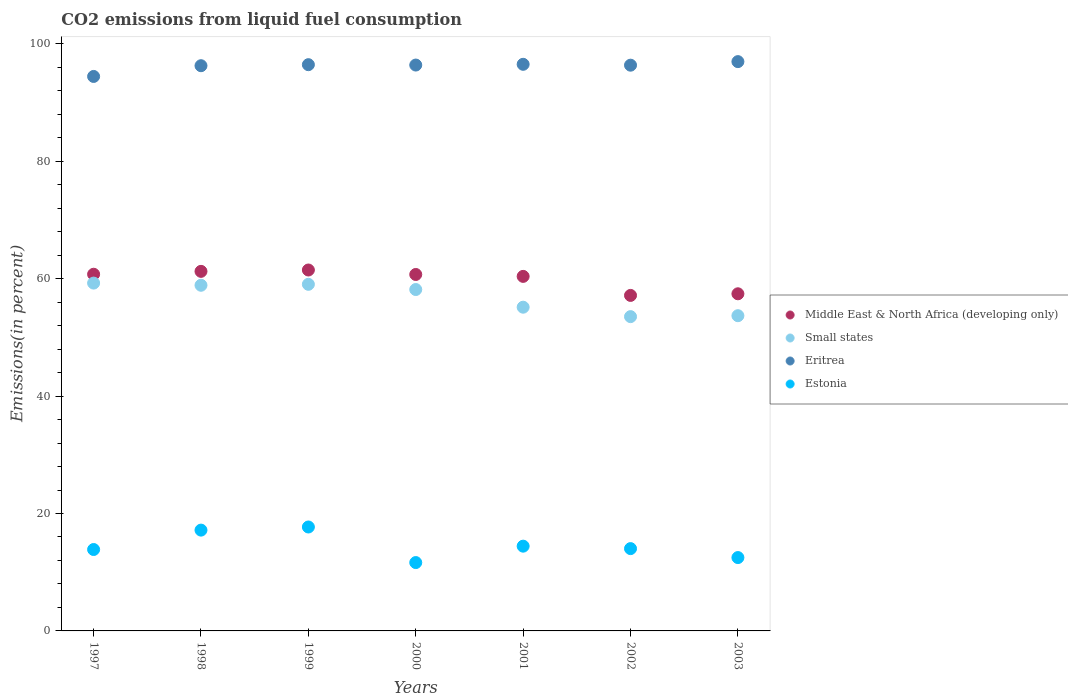How many different coloured dotlines are there?
Give a very brief answer. 4. What is the total CO2 emitted in Estonia in 2000?
Your response must be concise. 11.64. Across all years, what is the maximum total CO2 emitted in Eritrea?
Give a very brief answer. 96.97. Across all years, what is the minimum total CO2 emitted in Small states?
Keep it short and to the point. 53.53. In which year was the total CO2 emitted in Middle East & North Africa (developing only) maximum?
Make the answer very short. 1999. In which year was the total CO2 emitted in Middle East & North Africa (developing only) minimum?
Ensure brevity in your answer.  2002. What is the total total CO2 emitted in Small states in the graph?
Your answer should be very brief. 397.68. What is the difference between the total CO2 emitted in Small states in 2000 and that in 2003?
Offer a very short reply. 4.46. What is the difference between the total CO2 emitted in Middle East & North Africa (developing only) in 1999 and the total CO2 emitted in Estonia in 2001?
Offer a terse response. 47.04. What is the average total CO2 emitted in Small states per year?
Provide a short and direct response. 56.81. In the year 2003, what is the difference between the total CO2 emitted in Small states and total CO2 emitted in Estonia?
Make the answer very short. 41.2. In how many years, is the total CO2 emitted in Small states greater than 88 %?
Your answer should be compact. 0. What is the ratio of the total CO2 emitted in Middle East & North Africa (developing only) in 1999 to that in 2003?
Your answer should be compact. 1.07. Is the total CO2 emitted in Small states in 1998 less than that in 2003?
Offer a terse response. No. What is the difference between the highest and the second highest total CO2 emitted in Middle East & North Africa (developing only)?
Your response must be concise. 0.23. What is the difference between the highest and the lowest total CO2 emitted in Eritrea?
Keep it short and to the point. 2.53. Is the sum of the total CO2 emitted in Small states in 2000 and 2003 greater than the maximum total CO2 emitted in Middle East & North Africa (developing only) across all years?
Offer a terse response. Yes. Is it the case that in every year, the sum of the total CO2 emitted in Small states and total CO2 emitted in Eritrea  is greater than the sum of total CO2 emitted in Middle East & North Africa (developing only) and total CO2 emitted in Estonia?
Your response must be concise. Yes. Is it the case that in every year, the sum of the total CO2 emitted in Estonia and total CO2 emitted in Small states  is greater than the total CO2 emitted in Eritrea?
Make the answer very short. No. How many years are there in the graph?
Keep it short and to the point. 7. Are the values on the major ticks of Y-axis written in scientific E-notation?
Offer a terse response. No. Does the graph contain grids?
Your answer should be very brief. No. Where does the legend appear in the graph?
Make the answer very short. Center right. How many legend labels are there?
Offer a terse response. 4. What is the title of the graph?
Ensure brevity in your answer.  CO2 emissions from liquid fuel consumption. Does "High income: nonOECD" appear as one of the legend labels in the graph?
Ensure brevity in your answer.  No. What is the label or title of the Y-axis?
Provide a short and direct response. Emissions(in percent). What is the Emissions(in percent) in Middle East & North Africa (developing only) in 1997?
Ensure brevity in your answer.  60.75. What is the Emissions(in percent) of Small states in 1997?
Offer a very short reply. 59.25. What is the Emissions(in percent) in Eritrea in 1997?
Ensure brevity in your answer.  94.44. What is the Emissions(in percent) in Estonia in 1997?
Offer a terse response. 13.87. What is the Emissions(in percent) in Middle East & North Africa (developing only) in 1998?
Offer a very short reply. 61.24. What is the Emissions(in percent) in Small states in 1998?
Ensure brevity in your answer.  58.88. What is the Emissions(in percent) of Eritrea in 1998?
Offer a very short reply. 96.27. What is the Emissions(in percent) in Estonia in 1998?
Make the answer very short. 17.17. What is the Emissions(in percent) in Middle East & North Africa (developing only) in 1999?
Offer a very short reply. 61.48. What is the Emissions(in percent) of Small states in 1999?
Offer a very short reply. 59.04. What is the Emissions(in percent) in Eritrea in 1999?
Offer a very short reply. 96.45. What is the Emissions(in percent) of Estonia in 1999?
Your answer should be very brief. 17.7. What is the Emissions(in percent) of Middle East & North Africa (developing only) in 2000?
Keep it short and to the point. 60.72. What is the Emissions(in percent) in Small states in 2000?
Ensure brevity in your answer.  58.15. What is the Emissions(in percent) in Eritrea in 2000?
Make the answer very short. 96.39. What is the Emissions(in percent) of Estonia in 2000?
Your answer should be compact. 11.64. What is the Emissions(in percent) in Middle East & North Africa (developing only) in 2001?
Provide a succinct answer. 60.39. What is the Emissions(in percent) of Small states in 2001?
Make the answer very short. 55.14. What is the Emissions(in percent) in Eritrea in 2001?
Provide a short and direct response. 96.51. What is the Emissions(in percent) of Estonia in 2001?
Offer a terse response. 14.44. What is the Emissions(in percent) in Middle East & North Africa (developing only) in 2002?
Keep it short and to the point. 57.15. What is the Emissions(in percent) in Small states in 2002?
Your answer should be very brief. 53.53. What is the Emissions(in percent) in Eritrea in 2002?
Provide a succinct answer. 96.36. What is the Emissions(in percent) of Estonia in 2002?
Your response must be concise. 14.02. What is the Emissions(in percent) in Middle East & North Africa (developing only) in 2003?
Ensure brevity in your answer.  57.42. What is the Emissions(in percent) of Small states in 2003?
Your answer should be very brief. 53.69. What is the Emissions(in percent) of Eritrea in 2003?
Offer a very short reply. 96.97. What is the Emissions(in percent) of Estonia in 2003?
Provide a short and direct response. 12.49. Across all years, what is the maximum Emissions(in percent) of Middle East & North Africa (developing only)?
Your response must be concise. 61.48. Across all years, what is the maximum Emissions(in percent) of Small states?
Give a very brief answer. 59.25. Across all years, what is the maximum Emissions(in percent) in Eritrea?
Ensure brevity in your answer.  96.97. Across all years, what is the maximum Emissions(in percent) of Estonia?
Your response must be concise. 17.7. Across all years, what is the minimum Emissions(in percent) in Middle East & North Africa (developing only)?
Provide a succinct answer. 57.15. Across all years, what is the minimum Emissions(in percent) in Small states?
Provide a succinct answer. 53.53. Across all years, what is the minimum Emissions(in percent) of Eritrea?
Make the answer very short. 94.44. Across all years, what is the minimum Emissions(in percent) of Estonia?
Give a very brief answer. 11.64. What is the total Emissions(in percent) in Middle East & North Africa (developing only) in the graph?
Your answer should be very brief. 419.15. What is the total Emissions(in percent) in Small states in the graph?
Offer a terse response. 397.68. What is the total Emissions(in percent) of Eritrea in the graph?
Provide a succinct answer. 673.4. What is the total Emissions(in percent) in Estonia in the graph?
Keep it short and to the point. 101.33. What is the difference between the Emissions(in percent) of Middle East & North Africa (developing only) in 1997 and that in 1998?
Provide a succinct answer. -0.49. What is the difference between the Emissions(in percent) of Small states in 1997 and that in 1998?
Your answer should be very brief. 0.37. What is the difference between the Emissions(in percent) of Eritrea in 1997 and that in 1998?
Give a very brief answer. -1.83. What is the difference between the Emissions(in percent) of Estonia in 1997 and that in 1998?
Ensure brevity in your answer.  -3.3. What is the difference between the Emissions(in percent) of Middle East & North Africa (developing only) in 1997 and that in 1999?
Make the answer very short. -0.72. What is the difference between the Emissions(in percent) of Small states in 1997 and that in 1999?
Keep it short and to the point. 0.21. What is the difference between the Emissions(in percent) in Eritrea in 1997 and that in 1999?
Your answer should be compact. -2.01. What is the difference between the Emissions(in percent) in Estonia in 1997 and that in 1999?
Ensure brevity in your answer.  -3.84. What is the difference between the Emissions(in percent) of Middle East & North Africa (developing only) in 1997 and that in 2000?
Give a very brief answer. 0.04. What is the difference between the Emissions(in percent) of Small states in 1997 and that in 2000?
Your answer should be compact. 1.1. What is the difference between the Emissions(in percent) in Eritrea in 1997 and that in 2000?
Offer a terse response. -1.94. What is the difference between the Emissions(in percent) of Estonia in 1997 and that in 2000?
Offer a terse response. 2.22. What is the difference between the Emissions(in percent) in Middle East & North Africa (developing only) in 1997 and that in 2001?
Keep it short and to the point. 0.37. What is the difference between the Emissions(in percent) of Small states in 1997 and that in 2001?
Provide a succinct answer. 4.11. What is the difference between the Emissions(in percent) in Eritrea in 1997 and that in 2001?
Provide a succinct answer. -2.07. What is the difference between the Emissions(in percent) of Estonia in 1997 and that in 2001?
Ensure brevity in your answer.  -0.57. What is the difference between the Emissions(in percent) in Middle East & North Africa (developing only) in 1997 and that in 2002?
Provide a succinct answer. 3.61. What is the difference between the Emissions(in percent) in Small states in 1997 and that in 2002?
Keep it short and to the point. 5.71. What is the difference between the Emissions(in percent) of Eritrea in 1997 and that in 2002?
Ensure brevity in your answer.  -1.92. What is the difference between the Emissions(in percent) of Estonia in 1997 and that in 2002?
Provide a succinct answer. -0.15. What is the difference between the Emissions(in percent) of Middle East & North Africa (developing only) in 1997 and that in 2003?
Keep it short and to the point. 3.33. What is the difference between the Emissions(in percent) in Small states in 1997 and that in 2003?
Provide a short and direct response. 5.55. What is the difference between the Emissions(in percent) of Eritrea in 1997 and that in 2003?
Offer a very short reply. -2.53. What is the difference between the Emissions(in percent) of Estonia in 1997 and that in 2003?
Provide a short and direct response. 1.37. What is the difference between the Emissions(in percent) of Middle East & North Africa (developing only) in 1998 and that in 1999?
Provide a short and direct response. -0.23. What is the difference between the Emissions(in percent) of Small states in 1998 and that in 1999?
Keep it short and to the point. -0.16. What is the difference between the Emissions(in percent) in Eritrea in 1998 and that in 1999?
Provide a short and direct response. -0.18. What is the difference between the Emissions(in percent) in Estonia in 1998 and that in 1999?
Your answer should be compact. -0.53. What is the difference between the Emissions(in percent) in Middle East & North Africa (developing only) in 1998 and that in 2000?
Offer a terse response. 0.53. What is the difference between the Emissions(in percent) in Small states in 1998 and that in 2000?
Make the answer very short. 0.73. What is the difference between the Emissions(in percent) of Eritrea in 1998 and that in 2000?
Make the answer very short. -0.11. What is the difference between the Emissions(in percent) of Estonia in 1998 and that in 2000?
Keep it short and to the point. 5.53. What is the difference between the Emissions(in percent) of Middle East & North Africa (developing only) in 1998 and that in 2001?
Provide a short and direct response. 0.86. What is the difference between the Emissions(in percent) in Small states in 1998 and that in 2001?
Make the answer very short. 3.74. What is the difference between the Emissions(in percent) of Eritrea in 1998 and that in 2001?
Give a very brief answer. -0.24. What is the difference between the Emissions(in percent) of Estonia in 1998 and that in 2001?
Offer a very short reply. 2.73. What is the difference between the Emissions(in percent) in Middle East & North Africa (developing only) in 1998 and that in 2002?
Your answer should be compact. 4.1. What is the difference between the Emissions(in percent) in Small states in 1998 and that in 2002?
Offer a terse response. 5.34. What is the difference between the Emissions(in percent) of Eritrea in 1998 and that in 2002?
Your answer should be very brief. -0.09. What is the difference between the Emissions(in percent) of Estonia in 1998 and that in 2002?
Make the answer very short. 3.15. What is the difference between the Emissions(in percent) in Middle East & North Africa (developing only) in 1998 and that in 2003?
Provide a short and direct response. 3.82. What is the difference between the Emissions(in percent) of Small states in 1998 and that in 2003?
Your response must be concise. 5.18. What is the difference between the Emissions(in percent) of Eritrea in 1998 and that in 2003?
Provide a short and direct response. -0.7. What is the difference between the Emissions(in percent) of Estonia in 1998 and that in 2003?
Provide a succinct answer. 4.68. What is the difference between the Emissions(in percent) in Middle East & North Africa (developing only) in 1999 and that in 2000?
Make the answer very short. 0.76. What is the difference between the Emissions(in percent) of Small states in 1999 and that in 2000?
Your response must be concise. 0.89. What is the difference between the Emissions(in percent) of Eritrea in 1999 and that in 2000?
Offer a very short reply. 0.06. What is the difference between the Emissions(in percent) of Estonia in 1999 and that in 2000?
Make the answer very short. 6.06. What is the difference between the Emissions(in percent) of Middle East & North Africa (developing only) in 1999 and that in 2001?
Your answer should be very brief. 1.09. What is the difference between the Emissions(in percent) in Small states in 1999 and that in 2001?
Your response must be concise. 3.9. What is the difference between the Emissions(in percent) in Eritrea in 1999 and that in 2001?
Your answer should be very brief. -0.06. What is the difference between the Emissions(in percent) in Estonia in 1999 and that in 2001?
Make the answer very short. 3.27. What is the difference between the Emissions(in percent) of Middle East & North Africa (developing only) in 1999 and that in 2002?
Give a very brief answer. 4.33. What is the difference between the Emissions(in percent) in Small states in 1999 and that in 2002?
Your answer should be compact. 5.5. What is the difference between the Emissions(in percent) in Eritrea in 1999 and that in 2002?
Offer a terse response. 0.09. What is the difference between the Emissions(in percent) in Estonia in 1999 and that in 2002?
Provide a short and direct response. 3.68. What is the difference between the Emissions(in percent) in Middle East & North Africa (developing only) in 1999 and that in 2003?
Offer a very short reply. 4.05. What is the difference between the Emissions(in percent) in Small states in 1999 and that in 2003?
Your response must be concise. 5.35. What is the difference between the Emissions(in percent) of Eritrea in 1999 and that in 2003?
Ensure brevity in your answer.  -0.52. What is the difference between the Emissions(in percent) in Estonia in 1999 and that in 2003?
Your answer should be very brief. 5.21. What is the difference between the Emissions(in percent) in Middle East & North Africa (developing only) in 2000 and that in 2001?
Give a very brief answer. 0.33. What is the difference between the Emissions(in percent) in Small states in 2000 and that in 2001?
Your response must be concise. 3.01. What is the difference between the Emissions(in percent) of Eritrea in 2000 and that in 2001?
Keep it short and to the point. -0.13. What is the difference between the Emissions(in percent) of Estonia in 2000 and that in 2001?
Provide a short and direct response. -2.79. What is the difference between the Emissions(in percent) in Middle East & North Africa (developing only) in 2000 and that in 2002?
Give a very brief answer. 3.57. What is the difference between the Emissions(in percent) of Small states in 2000 and that in 2002?
Keep it short and to the point. 4.62. What is the difference between the Emissions(in percent) of Eritrea in 2000 and that in 2002?
Your answer should be very brief. 0.02. What is the difference between the Emissions(in percent) in Estonia in 2000 and that in 2002?
Your answer should be compact. -2.38. What is the difference between the Emissions(in percent) of Middle East & North Africa (developing only) in 2000 and that in 2003?
Your response must be concise. 3.29. What is the difference between the Emissions(in percent) of Small states in 2000 and that in 2003?
Provide a succinct answer. 4.46. What is the difference between the Emissions(in percent) of Eritrea in 2000 and that in 2003?
Provide a succinct answer. -0.58. What is the difference between the Emissions(in percent) of Estonia in 2000 and that in 2003?
Provide a succinct answer. -0.85. What is the difference between the Emissions(in percent) in Middle East & North Africa (developing only) in 2001 and that in 2002?
Your answer should be very brief. 3.24. What is the difference between the Emissions(in percent) in Small states in 2001 and that in 2002?
Keep it short and to the point. 1.61. What is the difference between the Emissions(in percent) in Eritrea in 2001 and that in 2002?
Your answer should be very brief. 0.15. What is the difference between the Emissions(in percent) of Estonia in 2001 and that in 2002?
Ensure brevity in your answer.  0.42. What is the difference between the Emissions(in percent) of Middle East & North Africa (developing only) in 2001 and that in 2003?
Your answer should be compact. 2.96. What is the difference between the Emissions(in percent) in Small states in 2001 and that in 2003?
Make the answer very short. 1.45. What is the difference between the Emissions(in percent) of Eritrea in 2001 and that in 2003?
Make the answer very short. -0.46. What is the difference between the Emissions(in percent) in Estonia in 2001 and that in 2003?
Provide a short and direct response. 1.94. What is the difference between the Emissions(in percent) of Middle East & North Africa (developing only) in 2002 and that in 2003?
Ensure brevity in your answer.  -0.28. What is the difference between the Emissions(in percent) in Small states in 2002 and that in 2003?
Keep it short and to the point. -0.16. What is the difference between the Emissions(in percent) of Eritrea in 2002 and that in 2003?
Ensure brevity in your answer.  -0.61. What is the difference between the Emissions(in percent) in Estonia in 2002 and that in 2003?
Offer a terse response. 1.52. What is the difference between the Emissions(in percent) in Middle East & North Africa (developing only) in 1997 and the Emissions(in percent) in Small states in 1998?
Provide a short and direct response. 1.88. What is the difference between the Emissions(in percent) of Middle East & North Africa (developing only) in 1997 and the Emissions(in percent) of Eritrea in 1998?
Provide a short and direct response. -35.52. What is the difference between the Emissions(in percent) of Middle East & North Africa (developing only) in 1997 and the Emissions(in percent) of Estonia in 1998?
Provide a short and direct response. 43.58. What is the difference between the Emissions(in percent) in Small states in 1997 and the Emissions(in percent) in Eritrea in 1998?
Provide a short and direct response. -37.03. What is the difference between the Emissions(in percent) of Small states in 1997 and the Emissions(in percent) of Estonia in 1998?
Your response must be concise. 42.08. What is the difference between the Emissions(in percent) in Eritrea in 1997 and the Emissions(in percent) in Estonia in 1998?
Make the answer very short. 77.27. What is the difference between the Emissions(in percent) of Middle East & North Africa (developing only) in 1997 and the Emissions(in percent) of Small states in 1999?
Keep it short and to the point. 1.72. What is the difference between the Emissions(in percent) in Middle East & North Africa (developing only) in 1997 and the Emissions(in percent) in Eritrea in 1999?
Give a very brief answer. -35.69. What is the difference between the Emissions(in percent) of Middle East & North Africa (developing only) in 1997 and the Emissions(in percent) of Estonia in 1999?
Keep it short and to the point. 43.05. What is the difference between the Emissions(in percent) in Small states in 1997 and the Emissions(in percent) in Eritrea in 1999?
Your answer should be compact. -37.2. What is the difference between the Emissions(in percent) of Small states in 1997 and the Emissions(in percent) of Estonia in 1999?
Your answer should be very brief. 41.54. What is the difference between the Emissions(in percent) of Eritrea in 1997 and the Emissions(in percent) of Estonia in 1999?
Offer a terse response. 76.74. What is the difference between the Emissions(in percent) in Middle East & North Africa (developing only) in 1997 and the Emissions(in percent) in Small states in 2000?
Your answer should be compact. 2.6. What is the difference between the Emissions(in percent) in Middle East & North Africa (developing only) in 1997 and the Emissions(in percent) in Eritrea in 2000?
Your answer should be very brief. -35.63. What is the difference between the Emissions(in percent) of Middle East & North Africa (developing only) in 1997 and the Emissions(in percent) of Estonia in 2000?
Ensure brevity in your answer.  49.11. What is the difference between the Emissions(in percent) in Small states in 1997 and the Emissions(in percent) in Eritrea in 2000?
Keep it short and to the point. -37.14. What is the difference between the Emissions(in percent) of Small states in 1997 and the Emissions(in percent) of Estonia in 2000?
Your answer should be compact. 47.6. What is the difference between the Emissions(in percent) of Eritrea in 1997 and the Emissions(in percent) of Estonia in 2000?
Your response must be concise. 82.8. What is the difference between the Emissions(in percent) in Middle East & North Africa (developing only) in 1997 and the Emissions(in percent) in Small states in 2001?
Offer a very short reply. 5.62. What is the difference between the Emissions(in percent) of Middle East & North Africa (developing only) in 1997 and the Emissions(in percent) of Eritrea in 2001?
Keep it short and to the point. -35.76. What is the difference between the Emissions(in percent) of Middle East & North Africa (developing only) in 1997 and the Emissions(in percent) of Estonia in 2001?
Give a very brief answer. 46.32. What is the difference between the Emissions(in percent) in Small states in 1997 and the Emissions(in percent) in Eritrea in 2001?
Make the answer very short. -37.27. What is the difference between the Emissions(in percent) in Small states in 1997 and the Emissions(in percent) in Estonia in 2001?
Your response must be concise. 44.81. What is the difference between the Emissions(in percent) in Eritrea in 1997 and the Emissions(in percent) in Estonia in 2001?
Your answer should be compact. 80.01. What is the difference between the Emissions(in percent) in Middle East & North Africa (developing only) in 1997 and the Emissions(in percent) in Small states in 2002?
Your answer should be very brief. 7.22. What is the difference between the Emissions(in percent) of Middle East & North Africa (developing only) in 1997 and the Emissions(in percent) of Eritrea in 2002?
Your response must be concise. -35.61. What is the difference between the Emissions(in percent) of Middle East & North Africa (developing only) in 1997 and the Emissions(in percent) of Estonia in 2002?
Your answer should be very brief. 46.74. What is the difference between the Emissions(in percent) of Small states in 1997 and the Emissions(in percent) of Eritrea in 2002?
Keep it short and to the point. -37.12. What is the difference between the Emissions(in percent) in Small states in 1997 and the Emissions(in percent) in Estonia in 2002?
Give a very brief answer. 45.23. What is the difference between the Emissions(in percent) in Eritrea in 1997 and the Emissions(in percent) in Estonia in 2002?
Offer a very short reply. 80.43. What is the difference between the Emissions(in percent) of Middle East & North Africa (developing only) in 1997 and the Emissions(in percent) of Small states in 2003?
Provide a short and direct response. 7.06. What is the difference between the Emissions(in percent) of Middle East & North Africa (developing only) in 1997 and the Emissions(in percent) of Eritrea in 2003?
Make the answer very short. -36.21. What is the difference between the Emissions(in percent) in Middle East & North Africa (developing only) in 1997 and the Emissions(in percent) in Estonia in 2003?
Your answer should be compact. 48.26. What is the difference between the Emissions(in percent) of Small states in 1997 and the Emissions(in percent) of Eritrea in 2003?
Provide a succinct answer. -37.72. What is the difference between the Emissions(in percent) in Small states in 1997 and the Emissions(in percent) in Estonia in 2003?
Make the answer very short. 46.75. What is the difference between the Emissions(in percent) in Eritrea in 1997 and the Emissions(in percent) in Estonia in 2003?
Your answer should be very brief. 81.95. What is the difference between the Emissions(in percent) in Middle East & North Africa (developing only) in 1998 and the Emissions(in percent) in Small states in 1999?
Your answer should be compact. 2.21. What is the difference between the Emissions(in percent) of Middle East & North Africa (developing only) in 1998 and the Emissions(in percent) of Eritrea in 1999?
Your response must be concise. -35.21. What is the difference between the Emissions(in percent) of Middle East & North Africa (developing only) in 1998 and the Emissions(in percent) of Estonia in 1999?
Offer a terse response. 43.54. What is the difference between the Emissions(in percent) of Small states in 1998 and the Emissions(in percent) of Eritrea in 1999?
Your response must be concise. -37.57. What is the difference between the Emissions(in percent) of Small states in 1998 and the Emissions(in percent) of Estonia in 1999?
Give a very brief answer. 41.18. What is the difference between the Emissions(in percent) in Eritrea in 1998 and the Emissions(in percent) in Estonia in 1999?
Ensure brevity in your answer.  78.57. What is the difference between the Emissions(in percent) in Middle East & North Africa (developing only) in 1998 and the Emissions(in percent) in Small states in 2000?
Your response must be concise. 3.09. What is the difference between the Emissions(in percent) in Middle East & North Africa (developing only) in 1998 and the Emissions(in percent) in Eritrea in 2000?
Make the answer very short. -35.14. What is the difference between the Emissions(in percent) of Middle East & North Africa (developing only) in 1998 and the Emissions(in percent) of Estonia in 2000?
Your response must be concise. 49.6. What is the difference between the Emissions(in percent) of Small states in 1998 and the Emissions(in percent) of Eritrea in 2000?
Ensure brevity in your answer.  -37.51. What is the difference between the Emissions(in percent) of Small states in 1998 and the Emissions(in percent) of Estonia in 2000?
Your answer should be very brief. 47.24. What is the difference between the Emissions(in percent) in Eritrea in 1998 and the Emissions(in percent) in Estonia in 2000?
Offer a very short reply. 84.63. What is the difference between the Emissions(in percent) in Middle East & North Africa (developing only) in 1998 and the Emissions(in percent) in Small states in 2001?
Provide a succinct answer. 6.1. What is the difference between the Emissions(in percent) of Middle East & North Africa (developing only) in 1998 and the Emissions(in percent) of Eritrea in 2001?
Provide a succinct answer. -35.27. What is the difference between the Emissions(in percent) in Middle East & North Africa (developing only) in 1998 and the Emissions(in percent) in Estonia in 2001?
Offer a terse response. 46.81. What is the difference between the Emissions(in percent) in Small states in 1998 and the Emissions(in percent) in Eritrea in 2001?
Keep it short and to the point. -37.63. What is the difference between the Emissions(in percent) of Small states in 1998 and the Emissions(in percent) of Estonia in 2001?
Make the answer very short. 44.44. What is the difference between the Emissions(in percent) of Eritrea in 1998 and the Emissions(in percent) of Estonia in 2001?
Your answer should be compact. 81.84. What is the difference between the Emissions(in percent) of Middle East & North Africa (developing only) in 1998 and the Emissions(in percent) of Small states in 2002?
Your answer should be compact. 7.71. What is the difference between the Emissions(in percent) of Middle East & North Africa (developing only) in 1998 and the Emissions(in percent) of Eritrea in 2002?
Provide a short and direct response. -35.12. What is the difference between the Emissions(in percent) in Middle East & North Africa (developing only) in 1998 and the Emissions(in percent) in Estonia in 2002?
Provide a short and direct response. 47.23. What is the difference between the Emissions(in percent) of Small states in 1998 and the Emissions(in percent) of Eritrea in 2002?
Make the answer very short. -37.49. What is the difference between the Emissions(in percent) in Small states in 1998 and the Emissions(in percent) in Estonia in 2002?
Your answer should be very brief. 44.86. What is the difference between the Emissions(in percent) in Eritrea in 1998 and the Emissions(in percent) in Estonia in 2002?
Provide a short and direct response. 82.25. What is the difference between the Emissions(in percent) in Middle East & North Africa (developing only) in 1998 and the Emissions(in percent) in Small states in 2003?
Provide a succinct answer. 7.55. What is the difference between the Emissions(in percent) in Middle East & North Africa (developing only) in 1998 and the Emissions(in percent) in Eritrea in 2003?
Provide a succinct answer. -35.73. What is the difference between the Emissions(in percent) of Middle East & North Africa (developing only) in 1998 and the Emissions(in percent) of Estonia in 2003?
Offer a terse response. 48.75. What is the difference between the Emissions(in percent) in Small states in 1998 and the Emissions(in percent) in Eritrea in 2003?
Offer a terse response. -38.09. What is the difference between the Emissions(in percent) in Small states in 1998 and the Emissions(in percent) in Estonia in 2003?
Offer a very short reply. 46.38. What is the difference between the Emissions(in percent) in Eritrea in 1998 and the Emissions(in percent) in Estonia in 2003?
Your response must be concise. 83.78. What is the difference between the Emissions(in percent) of Middle East & North Africa (developing only) in 1999 and the Emissions(in percent) of Small states in 2000?
Your answer should be compact. 3.33. What is the difference between the Emissions(in percent) of Middle East & North Africa (developing only) in 1999 and the Emissions(in percent) of Eritrea in 2000?
Provide a succinct answer. -34.91. What is the difference between the Emissions(in percent) in Middle East & North Africa (developing only) in 1999 and the Emissions(in percent) in Estonia in 2000?
Offer a terse response. 49.83. What is the difference between the Emissions(in percent) of Small states in 1999 and the Emissions(in percent) of Eritrea in 2000?
Your response must be concise. -37.35. What is the difference between the Emissions(in percent) in Small states in 1999 and the Emissions(in percent) in Estonia in 2000?
Your response must be concise. 47.4. What is the difference between the Emissions(in percent) in Eritrea in 1999 and the Emissions(in percent) in Estonia in 2000?
Make the answer very short. 84.81. What is the difference between the Emissions(in percent) in Middle East & North Africa (developing only) in 1999 and the Emissions(in percent) in Small states in 2001?
Give a very brief answer. 6.34. What is the difference between the Emissions(in percent) of Middle East & North Africa (developing only) in 1999 and the Emissions(in percent) of Eritrea in 2001?
Ensure brevity in your answer.  -35.04. What is the difference between the Emissions(in percent) in Middle East & North Africa (developing only) in 1999 and the Emissions(in percent) in Estonia in 2001?
Offer a very short reply. 47.04. What is the difference between the Emissions(in percent) of Small states in 1999 and the Emissions(in percent) of Eritrea in 2001?
Ensure brevity in your answer.  -37.47. What is the difference between the Emissions(in percent) of Small states in 1999 and the Emissions(in percent) of Estonia in 2001?
Provide a short and direct response. 44.6. What is the difference between the Emissions(in percent) in Eritrea in 1999 and the Emissions(in percent) in Estonia in 2001?
Ensure brevity in your answer.  82.01. What is the difference between the Emissions(in percent) of Middle East & North Africa (developing only) in 1999 and the Emissions(in percent) of Small states in 2002?
Your response must be concise. 7.94. What is the difference between the Emissions(in percent) of Middle East & North Africa (developing only) in 1999 and the Emissions(in percent) of Eritrea in 2002?
Your answer should be very brief. -34.89. What is the difference between the Emissions(in percent) of Middle East & North Africa (developing only) in 1999 and the Emissions(in percent) of Estonia in 2002?
Provide a short and direct response. 47.46. What is the difference between the Emissions(in percent) of Small states in 1999 and the Emissions(in percent) of Eritrea in 2002?
Ensure brevity in your answer.  -37.33. What is the difference between the Emissions(in percent) in Small states in 1999 and the Emissions(in percent) in Estonia in 2002?
Your answer should be compact. 45.02. What is the difference between the Emissions(in percent) in Eritrea in 1999 and the Emissions(in percent) in Estonia in 2002?
Keep it short and to the point. 82.43. What is the difference between the Emissions(in percent) in Middle East & North Africa (developing only) in 1999 and the Emissions(in percent) in Small states in 2003?
Your answer should be compact. 7.78. What is the difference between the Emissions(in percent) in Middle East & North Africa (developing only) in 1999 and the Emissions(in percent) in Eritrea in 2003?
Your answer should be very brief. -35.49. What is the difference between the Emissions(in percent) in Middle East & North Africa (developing only) in 1999 and the Emissions(in percent) in Estonia in 2003?
Provide a succinct answer. 48.98. What is the difference between the Emissions(in percent) in Small states in 1999 and the Emissions(in percent) in Eritrea in 2003?
Offer a very short reply. -37.93. What is the difference between the Emissions(in percent) in Small states in 1999 and the Emissions(in percent) in Estonia in 2003?
Offer a terse response. 46.54. What is the difference between the Emissions(in percent) in Eritrea in 1999 and the Emissions(in percent) in Estonia in 2003?
Offer a terse response. 83.96. What is the difference between the Emissions(in percent) of Middle East & North Africa (developing only) in 2000 and the Emissions(in percent) of Small states in 2001?
Your response must be concise. 5.58. What is the difference between the Emissions(in percent) in Middle East & North Africa (developing only) in 2000 and the Emissions(in percent) in Eritrea in 2001?
Offer a very short reply. -35.8. What is the difference between the Emissions(in percent) in Middle East & North Africa (developing only) in 2000 and the Emissions(in percent) in Estonia in 2001?
Ensure brevity in your answer.  46.28. What is the difference between the Emissions(in percent) of Small states in 2000 and the Emissions(in percent) of Eritrea in 2001?
Your response must be concise. -38.36. What is the difference between the Emissions(in percent) in Small states in 2000 and the Emissions(in percent) in Estonia in 2001?
Keep it short and to the point. 43.71. What is the difference between the Emissions(in percent) in Eritrea in 2000 and the Emissions(in percent) in Estonia in 2001?
Your answer should be very brief. 81.95. What is the difference between the Emissions(in percent) in Middle East & North Africa (developing only) in 2000 and the Emissions(in percent) in Small states in 2002?
Provide a succinct answer. 7.18. What is the difference between the Emissions(in percent) of Middle East & North Africa (developing only) in 2000 and the Emissions(in percent) of Eritrea in 2002?
Your answer should be very brief. -35.65. What is the difference between the Emissions(in percent) of Middle East & North Africa (developing only) in 2000 and the Emissions(in percent) of Estonia in 2002?
Keep it short and to the point. 46.7. What is the difference between the Emissions(in percent) of Small states in 2000 and the Emissions(in percent) of Eritrea in 2002?
Ensure brevity in your answer.  -38.21. What is the difference between the Emissions(in percent) of Small states in 2000 and the Emissions(in percent) of Estonia in 2002?
Ensure brevity in your answer.  44.13. What is the difference between the Emissions(in percent) in Eritrea in 2000 and the Emissions(in percent) in Estonia in 2002?
Your response must be concise. 82.37. What is the difference between the Emissions(in percent) of Middle East & North Africa (developing only) in 2000 and the Emissions(in percent) of Small states in 2003?
Your response must be concise. 7.02. What is the difference between the Emissions(in percent) in Middle East & North Africa (developing only) in 2000 and the Emissions(in percent) in Eritrea in 2003?
Provide a short and direct response. -36.25. What is the difference between the Emissions(in percent) in Middle East & North Africa (developing only) in 2000 and the Emissions(in percent) in Estonia in 2003?
Provide a succinct answer. 48.22. What is the difference between the Emissions(in percent) of Small states in 2000 and the Emissions(in percent) of Eritrea in 2003?
Make the answer very short. -38.82. What is the difference between the Emissions(in percent) in Small states in 2000 and the Emissions(in percent) in Estonia in 2003?
Provide a short and direct response. 45.66. What is the difference between the Emissions(in percent) of Eritrea in 2000 and the Emissions(in percent) of Estonia in 2003?
Provide a succinct answer. 83.89. What is the difference between the Emissions(in percent) in Middle East & North Africa (developing only) in 2001 and the Emissions(in percent) in Small states in 2002?
Offer a very short reply. 6.85. What is the difference between the Emissions(in percent) in Middle East & North Africa (developing only) in 2001 and the Emissions(in percent) in Eritrea in 2002?
Provide a succinct answer. -35.97. What is the difference between the Emissions(in percent) of Middle East & North Africa (developing only) in 2001 and the Emissions(in percent) of Estonia in 2002?
Your answer should be very brief. 46.37. What is the difference between the Emissions(in percent) in Small states in 2001 and the Emissions(in percent) in Eritrea in 2002?
Give a very brief answer. -41.22. What is the difference between the Emissions(in percent) of Small states in 2001 and the Emissions(in percent) of Estonia in 2002?
Keep it short and to the point. 41.12. What is the difference between the Emissions(in percent) in Eritrea in 2001 and the Emissions(in percent) in Estonia in 2002?
Your answer should be compact. 82.49. What is the difference between the Emissions(in percent) in Middle East & North Africa (developing only) in 2001 and the Emissions(in percent) in Small states in 2003?
Offer a very short reply. 6.7. What is the difference between the Emissions(in percent) in Middle East & North Africa (developing only) in 2001 and the Emissions(in percent) in Eritrea in 2003?
Offer a very short reply. -36.58. What is the difference between the Emissions(in percent) of Middle East & North Africa (developing only) in 2001 and the Emissions(in percent) of Estonia in 2003?
Your response must be concise. 47.89. What is the difference between the Emissions(in percent) in Small states in 2001 and the Emissions(in percent) in Eritrea in 2003?
Provide a short and direct response. -41.83. What is the difference between the Emissions(in percent) in Small states in 2001 and the Emissions(in percent) in Estonia in 2003?
Provide a short and direct response. 42.64. What is the difference between the Emissions(in percent) of Eritrea in 2001 and the Emissions(in percent) of Estonia in 2003?
Offer a terse response. 84.02. What is the difference between the Emissions(in percent) in Middle East & North Africa (developing only) in 2002 and the Emissions(in percent) in Small states in 2003?
Your answer should be compact. 3.45. What is the difference between the Emissions(in percent) in Middle East & North Africa (developing only) in 2002 and the Emissions(in percent) in Eritrea in 2003?
Your answer should be compact. -39.82. What is the difference between the Emissions(in percent) in Middle East & North Africa (developing only) in 2002 and the Emissions(in percent) in Estonia in 2003?
Provide a short and direct response. 44.65. What is the difference between the Emissions(in percent) of Small states in 2002 and the Emissions(in percent) of Eritrea in 2003?
Your response must be concise. -43.44. What is the difference between the Emissions(in percent) of Small states in 2002 and the Emissions(in percent) of Estonia in 2003?
Make the answer very short. 41.04. What is the difference between the Emissions(in percent) of Eritrea in 2002 and the Emissions(in percent) of Estonia in 2003?
Offer a very short reply. 83.87. What is the average Emissions(in percent) of Middle East & North Africa (developing only) per year?
Your answer should be compact. 59.88. What is the average Emissions(in percent) of Small states per year?
Your answer should be compact. 56.81. What is the average Emissions(in percent) in Eritrea per year?
Provide a succinct answer. 96.2. What is the average Emissions(in percent) of Estonia per year?
Offer a terse response. 14.48. In the year 1997, what is the difference between the Emissions(in percent) of Middle East & North Africa (developing only) and Emissions(in percent) of Small states?
Provide a short and direct response. 1.51. In the year 1997, what is the difference between the Emissions(in percent) of Middle East & North Africa (developing only) and Emissions(in percent) of Eritrea?
Your answer should be very brief. -33.69. In the year 1997, what is the difference between the Emissions(in percent) in Middle East & North Africa (developing only) and Emissions(in percent) in Estonia?
Give a very brief answer. 46.89. In the year 1997, what is the difference between the Emissions(in percent) in Small states and Emissions(in percent) in Eritrea?
Provide a succinct answer. -35.2. In the year 1997, what is the difference between the Emissions(in percent) in Small states and Emissions(in percent) in Estonia?
Keep it short and to the point. 45.38. In the year 1997, what is the difference between the Emissions(in percent) of Eritrea and Emissions(in percent) of Estonia?
Provide a succinct answer. 80.58. In the year 1998, what is the difference between the Emissions(in percent) of Middle East & North Africa (developing only) and Emissions(in percent) of Small states?
Offer a terse response. 2.37. In the year 1998, what is the difference between the Emissions(in percent) in Middle East & North Africa (developing only) and Emissions(in percent) in Eritrea?
Offer a terse response. -35.03. In the year 1998, what is the difference between the Emissions(in percent) of Middle East & North Africa (developing only) and Emissions(in percent) of Estonia?
Your answer should be very brief. 44.07. In the year 1998, what is the difference between the Emissions(in percent) of Small states and Emissions(in percent) of Eritrea?
Your answer should be compact. -37.4. In the year 1998, what is the difference between the Emissions(in percent) of Small states and Emissions(in percent) of Estonia?
Provide a succinct answer. 41.71. In the year 1998, what is the difference between the Emissions(in percent) of Eritrea and Emissions(in percent) of Estonia?
Your answer should be very brief. 79.1. In the year 1999, what is the difference between the Emissions(in percent) in Middle East & North Africa (developing only) and Emissions(in percent) in Small states?
Give a very brief answer. 2.44. In the year 1999, what is the difference between the Emissions(in percent) of Middle East & North Africa (developing only) and Emissions(in percent) of Eritrea?
Your answer should be compact. -34.97. In the year 1999, what is the difference between the Emissions(in percent) of Middle East & North Africa (developing only) and Emissions(in percent) of Estonia?
Offer a very short reply. 43.77. In the year 1999, what is the difference between the Emissions(in percent) in Small states and Emissions(in percent) in Eritrea?
Offer a terse response. -37.41. In the year 1999, what is the difference between the Emissions(in percent) of Small states and Emissions(in percent) of Estonia?
Provide a succinct answer. 41.34. In the year 1999, what is the difference between the Emissions(in percent) of Eritrea and Emissions(in percent) of Estonia?
Keep it short and to the point. 78.75. In the year 2000, what is the difference between the Emissions(in percent) of Middle East & North Africa (developing only) and Emissions(in percent) of Small states?
Offer a very short reply. 2.56. In the year 2000, what is the difference between the Emissions(in percent) in Middle East & North Africa (developing only) and Emissions(in percent) in Eritrea?
Your answer should be compact. -35.67. In the year 2000, what is the difference between the Emissions(in percent) in Middle East & North Africa (developing only) and Emissions(in percent) in Estonia?
Offer a terse response. 49.07. In the year 2000, what is the difference between the Emissions(in percent) of Small states and Emissions(in percent) of Eritrea?
Give a very brief answer. -38.24. In the year 2000, what is the difference between the Emissions(in percent) in Small states and Emissions(in percent) in Estonia?
Your answer should be very brief. 46.51. In the year 2000, what is the difference between the Emissions(in percent) in Eritrea and Emissions(in percent) in Estonia?
Keep it short and to the point. 84.74. In the year 2001, what is the difference between the Emissions(in percent) of Middle East & North Africa (developing only) and Emissions(in percent) of Small states?
Keep it short and to the point. 5.25. In the year 2001, what is the difference between the Emissions(in percent) of Middle East & North Africa (developing only) and Emissions(in percent) of Eritrea?
Provide a succinct answer. -36.12. In the year 2001, what is the difference between the Emissions(in percent) of Middle East & North Africa (developing only) and Emissions(in percent) of Estonia?
Your answer should be compact. 45.95. In the year 2001, what is the difference between the Emissions(in percent) in Small states and Emissions(in percent) in Eritrea?
Offer a very short reply. -41.37. In the year 2001, what is the difference between the Emissions(in percent) in Small states and Emissions(in percent) in Estonia?
Offer a very short reply. 40.7. In the year 2001, what is the difference between the Emissions(in percent) of Eritrea and Emissions(in percent) of Estonia?
Your response must be concise. 82.07. In the year 2002, what is the difference between the Emissions(in percent) in Middle East & North Africa (developing only) and Emissions(in percent) in Small states?
Ensure brevity in your answer.  3.61. In the year 2002, what is the difference between the Emissions(in percent) in Middle East & North Africa (developing only) and Emissions(in percent) in Eritrea?
Offer a very short reply. -39.22. In the year 2002, what is the difference between the Emissions(in percent) in Middle East & North Africa (developing only) and Emissions(in percent) in Estonia?
Your answer should be very brief. 43.13. In the year 2002, what is the difference between the Emissions(in percent) in Small states and Emissions(in percent) in Eritrea?
Offer a terse response. -42.83. In the year 2002, what is the difference between the Emissions(in percent) in Small states and Emissions(in percent) in Estonia?
Your answer should be compact. 39.52. In the year 2002, what is the difference between the Emissions(in percent) in Eritrea and Emissions(in percent) in Estonia?
Make the answer very short. 82.34. In the year 2003, what is the difference between the Emissions(in percent) of Middle East & North Africa (developing only) and Emissions(in percent) of Small states?
Give a very brief answer. 3.73. In the year 2003, what is the difference between the Emissions(in percent) of Middle East & North Africa (developing only) and Emissions(in percent) of Eritrea?
Offer a very short reply. -39.55. In the year 2003, what is the difference between the Emissions(in percent) in Middle East & North Africa (developing only) and Emissions(in percent) in Estonia?
Your response must be concise. 44.93. In the year 2003, what is the difference between the Emissions(in percent) of Small states and Emissions(in percent) of Eritrea?
Your answer should be compact. -43.28. In the year 2003, what is the difference between the Emissions(in percent) in Small states and Emissions(in percent) in Estonia?
Your answer should be compact. 41.2. In the year 2003, what is the difference between the Emissions(in percent) in Eritrea and Emissions(in percent) in Estonia?
Provide a short and direct response. 84.48. What is the ratio of the Emissions(in percent) in Eritrea in 1997 to that in 1998?
Offer a terse response. 0.98. What is the ratio of the Emissions(in percent) of Estonia in 1997 to that in 1998?
Offer a terse response. 0.81. What is the ratio of the Emissions(in percent) in Middle East & North Africa (developing only) in 1997 to that in 1999?
Your response must be concise. 0.99. What is the ratio of the Emissions(in percent) of Small states in 1997 to that in 1999?
Your answer should be compact. 1. What is the ratio of the Emissions(in percent) in Eritrea in 1997 to that in 1999?
Your answer should be very brief. 0.98. What is the ratio of the Emissions(in percent) of Estonia in 1997 to that in 1999?
Offer a terse response. 0.78. What is the ratio of the Emissions(in percent) of Middle East & North Africa (developing only) in 1997 to that in 2000?
Keep it short and to the point. 1. What is the ratio of the Emissions(in percent) in Small states in 1997 to that in 2000?
Provide a succinct answer. 1.02. What is the ratio of the Emissions(in percent) in Eritrea in 1997 to that in 2000?
Offer a terse response. 0.98. What is the ratio of the Emissions(in percent) in Estonia in 1997 to that in 2000?
Keep it short and to the point. 1.19. What is the ratio of the Emissions(in percent) of Small states in 1997 to that in 2001?
Give a very brief answer. 1.07. What is the ratio of the Emissions(in percent) of Eritrea in 1997 to that in 2001?
Your answer should be very brief. 0.98. What is the ratio of the Emissions(in percent) of Estonia in 1997 to that in 2001?
Ensure brevity in your answer.  0.96. What is the ratio of the Emissions(in percent) of Middle East & North Africa (developing only) in 1997 to that in 2002?
Your answer should be compact. 1.06. What is the ratio of the Emissions(in percent) in Small states in 1997 to that in 2002?
Ensure brevity in your answer.  1.11. What is the ratio of the Emissions(in percent) in Eritrea in 1997 to that in 2002?
Offer a very short reply. 0.98. What is the ratio of the Emissions(in percent) in Middle East & North Africa (developing only) in 1997 to that in 2003?
Offer a terse response. 1.06. What is the ratio of the Emissions(in percent) of Small states in 1997 to that in 2003?
Give a very brief answer. 1.1. What is the ratio of the Emissions(in percent) in Estonia in 1997 to that in 2003?
Offer a terse response. 1.11. What is the ratio of the Emissions(in percent) in Middle East & North Africa (developing only) in 1998 to that in 1999?
Ensure brevity in your answer.  1. What is the ratio of the Emissions(in percent) in Small states in 1998 to that in 1999?
Provide a short and direct response. 1. What is the ratio of the Emissions(in percent) in Estonia in 1998 to that in 1999?
Your answer should be very brief. 0.97. What is the ratio of the Emissions(in percent) of Middle East & North Africa (developing only) in 1998 to that in 2000?
Your answer should be compact. 1.01. What is the ratio of the Emissions(in percent) of Small states in 1998 to that in 2000?
Offer a very short reply. 1.01. What is the ratio of the Emissions(in percent) of Eritrea in 1998 to that in 2000?
Keep it short and to the point. 1. What is the ratio of the Emissions(in percent) in Estonia in 1998 to that in 2000?
Ensure brevity in your answer.  1.47. What is the ratio of the Emissions(in percent) of Middle East & North Africa (developing only) in 1998 to that in 2001?
Your response must be concise. 1.01. What is the ratio of the Emissions(in percent) in Small states in 1998 to that in 2001?
Give a very brief answer. 1.07. What is the ratio of the Emissions(in percent) of Eritrea in 1998 to that in 2001?
Provide a succinct answer. 1. What is the ratio of the Emissions(in percent) in Estonia in 1998 to that in 2001?
Make the answer very short. 1.19. What is the ratio of the Emissions(in percent) in Middle East & North Africa (developing only) in 1998 to that in 2002?
Your answer should be very brief. 1.07. What is the ratio of the Emissions(in percent) of Small states in 1998 to that in 2002?
Provide a succinct answer. 1.1. What is the ratio of the Emissions(in percent) in Eritrea in 1998 to that in 2002?
Your answer should be very brief. 1. What is the ratio of the Emissions(in percent) in Estonia in 1998 to that in 2002?
Your answer should be compact. 1.22. What is the ratio of the Emissions(in percent) in Middle East & North Africa (developing only) in 1998 to that in 2003?
Provide a succinct answer. 1.07. What is the ratio of the Emissions(in percent) in Small states in 1998 to that in 2003?
Your answer should be very brief. 1.1. What is the ratio of the Emissions(in percent) in Estonia in 1998 to that in 2003?
Ensure brevity in your answer.  1.37. What is the ratio of the Emissions(in percent) in Middle East & North Africa (developing only) in 1999 to that in 2000?
Your response must be concise. 1.01. What is the ratio of the Emissions(in percent) in Small states in 1999 to that in 2000?
Offer a very short reply. 1.02. What is the ratio of the Emissions(in percent) of Estonia in 1999 to that in 2000?
Your answer should be very brief. 1.52. What is the ratio of the Emissions(in percent) in Middle East & North Africa (developing only) in 1999 to that in 2001?
Keep it short and to the point. 1.02. What is the ratio of the Emissions(in percent) of Small states in 1999 to that in 2001?
Keep it short and to the point. 1.07. What is the ratio of the Emissions(in percent) in Eritrea in 1999 to that in 2001?
Your answer should be very brief. 1. What is the ratio of the Emissions(in percent) in Estonia in 1999 to that in 2001?
Ensure brevity in your answer.  1.23. What is the ratio of the Emissions(in percent) in Middle East & North Africa (developing only) in 1999 to that in 2002?
Provide a short and direct response. 1.08. What is the ratio of the Emissions(in percent) in Small states in 1999 to that in 2002?
Provide a short and direct response. 1.1. What is the ratio of the Emissions(in percent) of Estonia in 1999 to that in 2002?
Offer a very short reply. 1.26. What is the ratio of the Emissions(in percent) of Middle East & North Africa (developing only) in 1999 to that in 2003?
Provide a short and direct response. 1.07. What is the ratio of the Emissions(in percent) of Small states in 1999 to that in 2003?
Offer a terse response. 1.1. What is the ratio of the Emissions(in percent) in Eritrea in 1999 to that in 2003?
Ensure brevity in your answer.  0.99. What is the ratio of the Emissions(in percent) of Estonia in 1999 to that in 2003?
Offer a terse response. 1.42. What is the ratio of the Emissions(in percent) in Middle East & North Africa (developing only) in 2000 to that in 2001?
Make the answer very short. 1.01. What is the ratio of the Emissions(in percent) of Small states in 2000 to that in 2001?
Keep it short and to the point. 1.05. What is the ratio of the Emissions(in percent) in Estonia in 2000 to that in 2001?
Give a very brief answer. 0.81. What is the ratio of the Emissions(in percent) in Middle East & North Africa (developing only) in 2000 to that in 2002?
Provide a short and direct response. 1.06. What is the ratio of the Emissions(in percent) in Small states in 2000 to that in 2002?
Make the answer very short. 1.09. What is the ratio of the Emissions(in percent) of Eritrea in 2000 to that in 2002?
Provide a succinct answer. 1. What is the ratio of the Emissions(in percent) in Estonia in 2000 to that in 2002?
Offer a very short reply. 0.83. What is the ratio of the Emissions(in percent) of Middle East & North Africa (developing only) in 2000 to that in 2003?
Ensure brevity in your answer.  1.06. What is the ratio of the Emissions(in percent) in Small states in 2000 to that in 2003?
Keep it short and to the point. 1.08. What is the ratio of the Emissions(in percent) of Eritrea in 2000 to that in 2003?
Provide a short and direct response. 0.99. What is the ratio of the Emissions(in percent) in Estonia in 2000 to that in 2003?
Ensure brevity in your answer.  0.93. What is the ratio of the Emissions(in percent) in Middle East & North Africa (developing only) in 2001 to that in 2002?
Offer a very short reply. 1.06. What is the ratio of the Emissions(in percent) of Small states in 2001 to that in 2002?
Your response must be concise. 1.03. What is the ratio of the Emissions(in percent) of Estonia in 2001 to that in 2002?
Keep it short and to the point. 1.03. What is the ratio of the Emissions(in percent) in Middle East & North Africa (developing only) in 2001 to that in 2003?
Offer a very short reply. 1.05. What is the ratio of the Emissions(in percent) of Small states in 2001 to that in 2003?
Ensure brevity in your answer.  1.03. What is the ratio of the Emissions(in percent) of Estonia in 2001 to that in 2003?
Your answer should be compact. 1.16. What is the ratio of the Emissions(in percent) of Eritrea in 2002 to that in 2003?
Your answer should be compact. 0.99. What is the ratio of the Emissions(in percent) in Estonia in 2002 to that in 2003?
Give a very brief answer. 1.12. What is the difference between the highest and the second highest Emissions(in percent) of Middle East & North Africa (developing only)?
Your response must be concise. 0.23. What is the difference between the highest and the second highest Emissions(in percent) of Small states?
Offer a terse response. 0.21. What is the difference between the highest and the second highest Emissions(in percent) in Eritrea?
Make the answer very short. 0.46. What is the difference between the highest and the second highest Emissions(in percent) of Estonia?
Provide a succinct answer. 0.53. What is the difference between the highest and the lowest Emissions(in percent) of Middle East & North Africa (developing only)?
Offer a very short reply. 4.33. What is the difference between the highest and the lowest Emissions(in percent) in Small states?
Provide a succinct answer. 5.71. What is the difference between the highest and the lowest Emissions(in percent) of Eritrea?
Your response must be concise. 2.53. What is the difference between the highest and the lowest Emissions(in percent) of Estonia?
Ensure brevity in your answer.  6.06. 